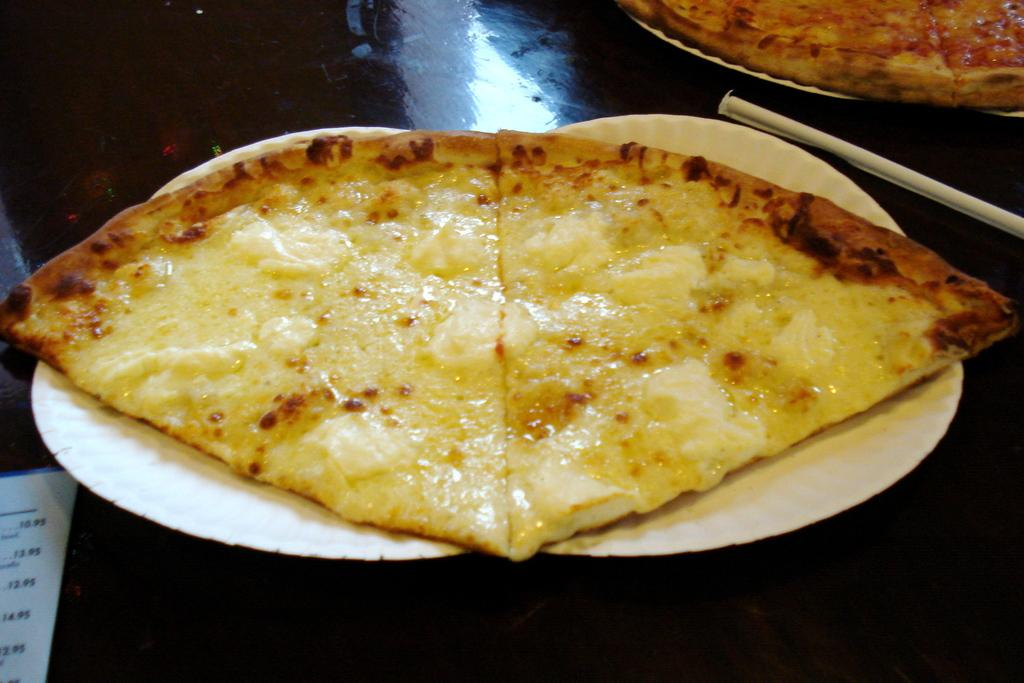What is present on the plates in the image? There is food in the plates in the image. What historical event is depicted in the image? There is no historical event depicted in the image; it simply shows food on plates. What type of recess is visible in the image? There is no recess present in the image; it only shows food on plates. 